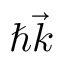<formula> <loc_0><loc_0><loc_500><loc_500>\hbar { \vec } { k }</formula> 